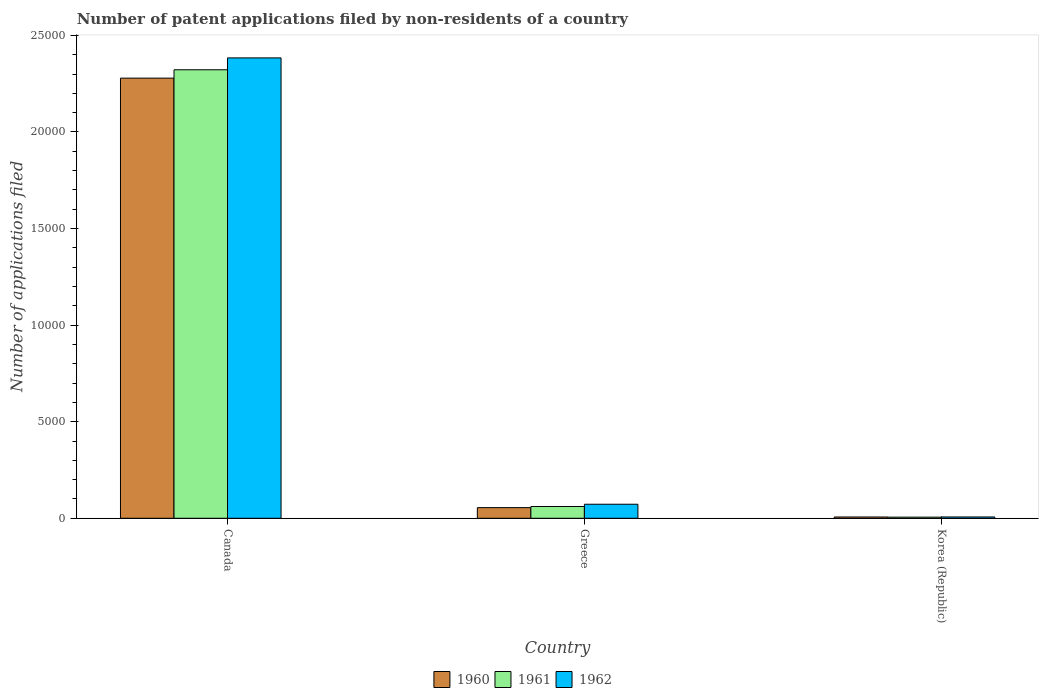How many different coloured bars are there?
Make the answer very short. 3. Are the number of bars on each tick of the X-axis equal?
Your answer should be compact. Yes. How many bars are there on the 3rd tick from the left?
Make the answer very short. 3. How many bars are there on the 1st tick from the right?
Your response must be concise. 3. In how many cases, is the number of bars for a given country not equal to the number of legend labels?
Offer a very short reply. 0. What is the number of applications filed in 1962 in Greece?
Provide a short and direct response. 726. Across all countries, what is the maximum number of applications filed in 1960?
Ensure brevity in your answer.  2.28e+04. Across all countries, what is the minimum number of applications filed in 1962?
Your answer should be compact. 68. In which country was the number of applications filed in 1961 minimum?
Make the answer very short. Korea (Republic). What is the total number of applications filed in 1962 in the graph?
Your response must be concise. 2.46e+04. What is the difference between the number of applications filed in 1960 in Greece and that in Korea (Republic)?
Your answer should be very brief. 485. What is the difference between the number of applications filed in 1960 in Canada and the number of applications filed in 1962 in Korea (Republic)?
Offer a very short reply. 2.27e+04. What is the average number of applications filed in 1961 per country?
Your response must be concise. 7962. What is the difference between the number of applications filed of/in 1962 and number of applications filed of/in 1961 in Korea (Republic)?
Your response must be concise. 10. In how many countries, is the number of applications filed in 1962 greater than 24000?
Provide a short and direct response. 0. What is the ratio of the number of applications filed in 1960 in Canada to that in Korea (Republic)?
Provide a short and direct response. 345.24. What is the difference between the highest and the second highest number of applications filed in 1960?
Provide a succinct answer. 2.27e+04. What is the difference between the highest and the lowest number of applications filed in 1962?
Give a very brief answer. 2.38e+04. Is the sum of the number of applications filed in 1960 in Canada and Greece greater than the maximum number of applications filed in 1962 across all countries?
Provide a short and direct response. No. What does the 1st bar from the right in Greece represents?
Provide a short and direct response. 1962. Are the values on the major ticks of Y-axis written in scientific E-notation?
Provide a succinct answer. No. Does the graph contain grids?
Ensure brevity in your answer.  No. Where does the legend appear in the graph?
Your answer should be very brief. Bottom center. What is the title of the graph?
Your response must be concise. Number of patent applications filed by non-residents of a country. What is the label or title of the X-axis?
Your answer should be compact. Country. What is the label or title of the Y-axis?
Your answer should be very brief. Number of applications filed. What is the Number of applications filed in 1960 in Canada?
Your answer should be very brief. 2.28e+04. What is the Number of applications filed of 1961 in Canada?
Your response must be concise. 2.32e+04. What is the Number of applications filed in 1962 in Canada?
Keep it short and to the point. 2.38e+04. What is the Number of applications filed in 1960 in Greece?
Give a very brief answer. 551. What is the Number of applications filed of 1961 in Greece?
Make the answer very short. 609. What is the Number of applications filed of 1962 in Greece?
Your answer should be very brief. 726. What is the Number of applications filed in 1961 in Korea (Republic)?
Provide a succinct answer. 58. What is the Number of applications filed of 1962 in Korea (Republic)?
Give a very brief answer. 68. Across all countries, what is the maximum Number of applications filed in 1960?
Ensure brevity in your answer.  2.28e+04. Across all countries, what is the maximum Number of applications filed in 1961?
Offer a terse response. 2.32e+04. Across all countries, what is the maximum Number of applications filed in 1962?
Provide a short and direct response. 2.38e+04. Across all countries, what is the minimum Number of applications filed of 1960?
Provide a short and direct response. 66. Across all countries, what is the minimum Number of applications filed in 1962?
Your answer should be compact. 68. What is the total Number of applications filed in 1960 in the graph?
Keep it short and to the point. 2.34e+04. What is the total Number of applications filed of 1961 in the graph?
Make the answer very short. 2.39e+04. What is the total Number of applications filed in 1962 in the graph?
Your answer should be very brief. 2.46e+04. What is the difference between the Number of applications filed of 1960 in Canada and that in Greece?
Offer a very short reply. 2.22e+04. What is the difference between the Number of applications filed in 1961 in Canada and that in Greece?
Provide a succinct answer. 2.26e+04. What is the difference between the Number of applications filed of 1962 in Canada and that in Greece?
Give a very brief answer. 2.31e+04. What is the difference between the Number of applications filed of 1960 in Canada and that in Korea (Republic)?
Your answer should be compact. 2.27e+04. What is the difference between the Number of applications filed in 1961 in Canada and that in Korea (Republic)?
Ensure brevity in your answer.  2.32e+04. What is the difference between the Number of applications filed in 1962 in Canada and that in Korea (Republic)?
Give a very brief answer. 2.38e+04. What is the difference between the Number of applications filed of 1960 in Greece and that in Korea (Republic)?
Provide a succinct answer. 485. What is the difference between the Number of applications filed of 1961 in Greece and that in Korea (Republic)?
Your answer should be very brief. 551. What is the difference between the Number of applications filed of 1962 in Greece and that in Korea (Republic)?
Offer a very short reply. 658. What is the difference between the Number of applications filed in 1960 in Canada and the Number of applications filed in 1961 in Greece?
Your answer should be compact. 2.22e+04. What is the difference between the Number of applications filed of 1960 in Canada and the Number of applications filed of 1962 in Greece?
Ensure brevity in your answer.  2.21e+04. What is the difference between the Number of applications filed in 1961 in Canada and the Number of applications filed in 1962 in Greece?
Ensure brevity in your answer.  2.25e+04. What is the difference between the Number of applications filed of 1960 in Canada and the Number of applications filed of 1961 in Korea (Republic)?
Provide a short and direct response. 2.27e+04. What is the difference between the Number of applications filed in 1960 in Canada and the Number of applications filed in 1962 in Korea (Republic)?
Give a very brief answer. 2.27e+04. What is the difference between the Number of applications filed in 1961 in Canada and the Number of applications filed in 1962 in Korea (Republic)?
Your response must be concise. 2.32e+04. What is the difference between the Number of applications filed in 1960 in Greece and the Number of applications filed in 1961 in Korea (Republic)?
Provide a succinct answer. 493. What is the difference between the Number of applications filed in 1960 in Greece and the Number of applications filed in 1962 in Korea (Republic)?
Provide a succinct answer. 483. What is the difference between the Number of applications filed of 1961 in Greece and the Number of applications filed of 1962 in Korea (Republic)?
Offer a terse response. 541. What is the average Number of applications filed in 1960 per country?
Offer a very short reply. 7801. What is the average Number of applications filed in 1961 per country?
Offer a very short reply. 7962. What is the average Number of applications filed of 1962 per country?
Keep it short and to the point. 8209.33. What is the difference between the Number of applications filed of 1960 and Number of applications filed of 1961 in Canada?
Offer a terse response. -433. What is the difference between the Number of applications filed in 1960 and Number of applications filed in 1962 in Canada?
Give a very brief answer. -1048. What is the difference between the Number of applications filed of 1961 and Number of applications filed of 1962 in Canada?
Your answer should be very brief. -615. What is the difference between the Number of applications filed of 1960 and Number of applications filed of 1961 in Greece?
Your answer should be compact. -58. What is the difference between the Number of applications filed of 1960 and Number of applications filed of 1962 in Greece?
Your response must be concise. -175. What is the difference between the Number of applications filed of 1961 and Number of applications filed of 1962 in Greece?
Your answer should be compact. -117. What is the difference between the Number of applications filed of 1960 and Number of applications filed of 1961 in Korea (Republic)?
Give a very brief answer. 8. What is the difference between the Number of applications filed of 1960 and Number of applications filed of 1962 in Korea (Republic)?
Your answer should be very brief. -2. What is the ratio of the Number of applications filed of 1960 in Canada to that in Greece?
Offer a terse response. 41.35. What is the ratio of the Number of applications filed of 1961 in Canada to that in Greece?
Keep it short and to the point. 38.13. What is the ratio of the Number of applications filed of 1962 in Canada to that in Greece?
Offer a very short reply. 32.83. What is the ratio of the Number of applications filed of 1960 in Canada to that in Korea (Republic)?
Provide a succinct answer. 345.24. What is the ratio of the Number of applications filed in 1961 in Canada to that in Korea (Republic)?
Your response must be concise. 400.33. What is the ratio of the Number of applications filed in 1962 in Canada to that in Korea (Republic)?
Offer a very short reply. 350.5. What is the ratio of the Number of applications filed in 1960 in Greece to that in Korea (Republic)?
Your answer should be very brief. 8.35. What is the ratio of the Number of applications filed in 1961 in Greece to that in Korea (Republic)?
Provide a succinct answer. 10.5. What is the ratio of the Number of applications filed in 1962 in Greece to that in Korea (Republic)?
Your answer should be compact. 10.68. What is the difference between the highest and the second highest Number of applications filed of 1960?
Keep it short and to the point. 2.22e+04. What is the difference between the highest and the second highest Number of applications filed in 1961?
Make the answer very short. 2.26e+04. What is the difference between the highest and the second highest Number of applications filed of 1962?
Make the answer very short. 2.31e+04. What is the difference between the highest and the lowest Number of applications filed in 1960?
Your answer should be very brief. 2.27e+04. What is the difference between the highest and the lowest Number of applications filed in 1961?
Your answer should be very brief. 2.32e+04. What is the difference between the highest and the lowest Number of applications filed of 1962?
Ensure brevity in your answer.  2.38e+04. 